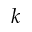<formula> <loc_0><loc_0><loc_500><loc_500>k</formula> 